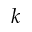<formula> <loc_0><loc_0><loc_500><loc_500>k</formula> 